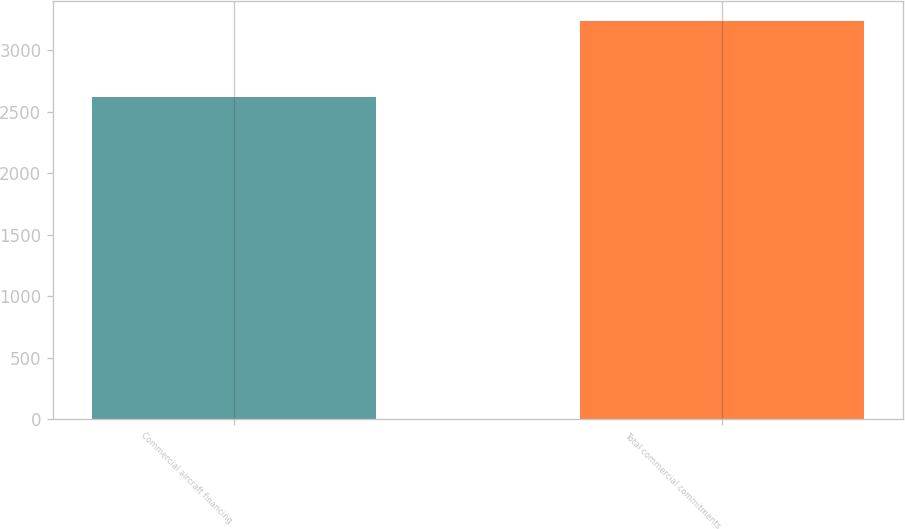Convert chart. <chart><loc_0><loc_0><loc_500><loc_500><bar_chart><fcel>Commercial aircraft financing<fcel>Total commercial commitments<nl><fcel>2621<fcel>3237<nl></chart> 